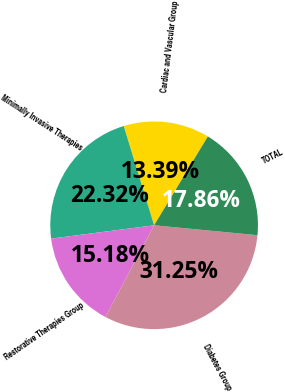<chart> <loc_0><loc_0><loc_500><loc_500><pie_chart><fcel>Cardiac and Vascular Group<fcel>Minimally Invasive Therapies<fcel>Restorative Therapies Group<fcel>Diabetes Group<fcel>TOTAL<nl><fcel>13.39%<fcel>22.32%<fcel>15.18%<fcel>31.25%<fcel>17.86%<nl></chart> 